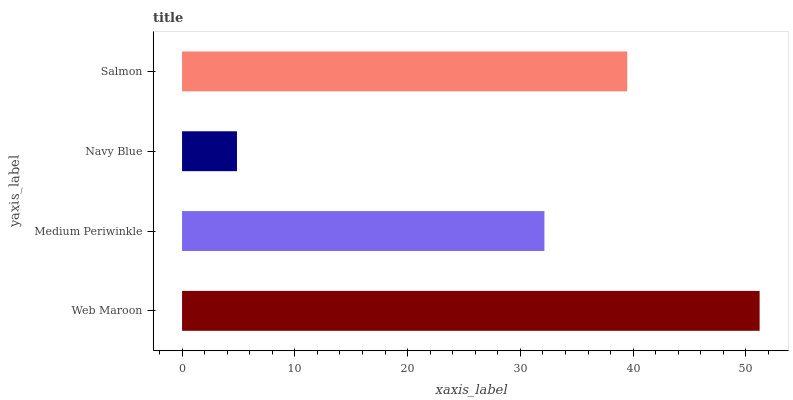Is Navy Blue the minimum?
Answer yes or no. Yes. Is Web Maroon the maximum?
Answer yes or no. Yes. Is Medium Periwinkle the minimum?
Answer yes or no. No. Is Medium Periwinkle the maximum?
Answer yes or no. No. Is Web Maroon greater than Medium Periwinkle?
Answer yes or no. Yes. Is Medium Periwinkle less than Web Maroon?
Answer yes or no. Yes. Is Medium Periwinkle greater than Web Maroon?
Answer yes or no. No. Is Web Maroon less than Medium Periwinkle?
Answer yes or no. No. Is Salmon the high median?
Answer yes or no. Yes. Is Medium Periwinkle the low median?
Answer yes or no. Yes. Is Navy Blue the high median?
Answer yes or no. No. Is Salmon the low median?
Answer yes or no. No. 